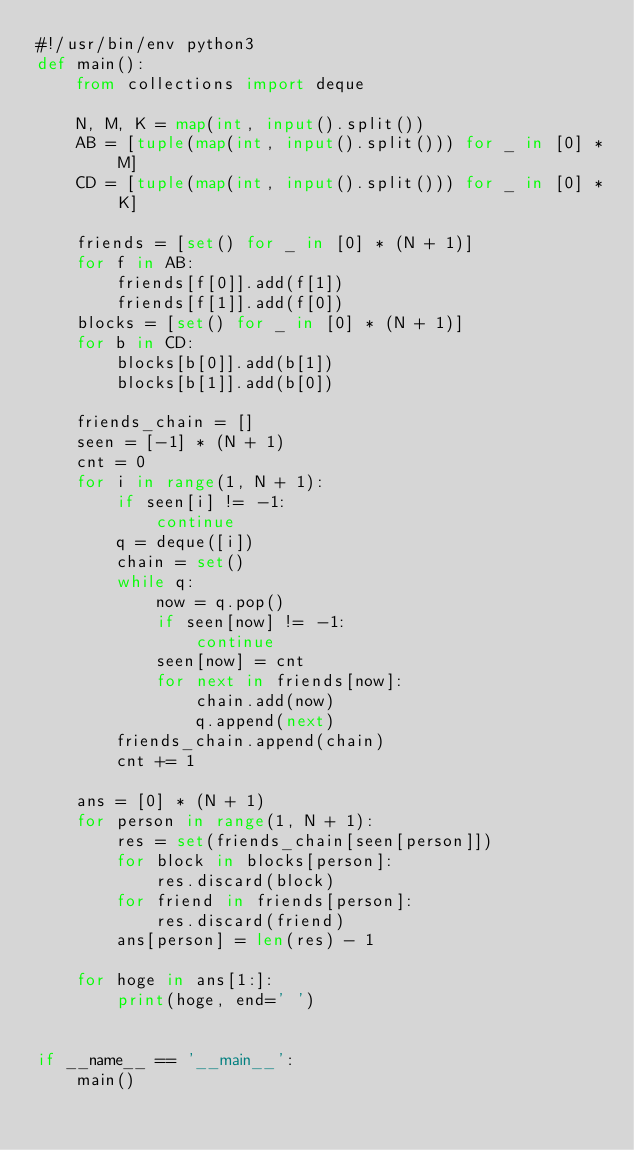Convert code to text. <code><loc_0><loc_0><loc_500><loc_500><_Python_>#!/usr/bin/env python3
def main():
    from collections import deque

    N, M, K = map(int, input().split())
    AB = [tuple(map(int, input().split())) for _ in [0] * M]
    CD = [tuple(map(int, input().split())) for _ in [0] * K]

    friends = [set() for _ in [0] * (N + 1)]
    for f in AB:
        friends[f[0]].add(f[1])
        friends[f[1]].add(f[0])
    blocks = [set() for _ in [0] * (N + 1)]
    for b in CD:
        blocks[b[0]].add(b[1])
        blocks[b[1]].add(b[0])

    friends_chain = []
    seen = [-1] * (N + 1)
    cnt = 0
    for i in range(1, N + 1):
        if seen[i] != -1:
            continue
        q = deque([i])
        chain = set()
        while q:
            now = q.pop()
            if seen[now] != -1:
                continue
            seen[now] = cnt
            for next in friends[now]:
                chain.add(now)
                q.append(next)
        friends_chain.append(chain)
        cnt += 1

    ans = [0] * (N + 1)
    for person in range(1, N + 1):
        res = set(friends_chain[seen[person]])
        for block in blocks[person]:
            res.discard(block)
        for friend in friends[person]:
            res.discard(friend)
        ans[person] = len(res) - 1
    
    for hoge in ans[1:]:
        print(hoge, end=' ')


if __name__ == '__main__':
    main()
</code> 